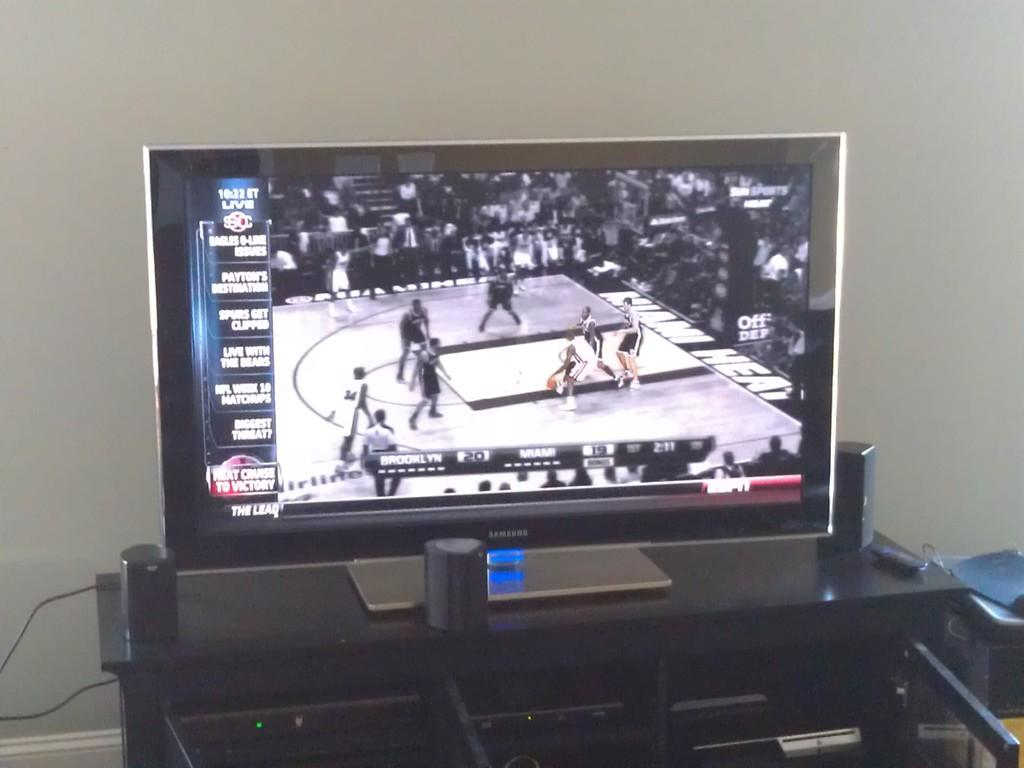<image>
Give a short and clear explanation of the subsequent image. A Samsung brand tv sitting on a glass table while showing a basketball game on the screen. 